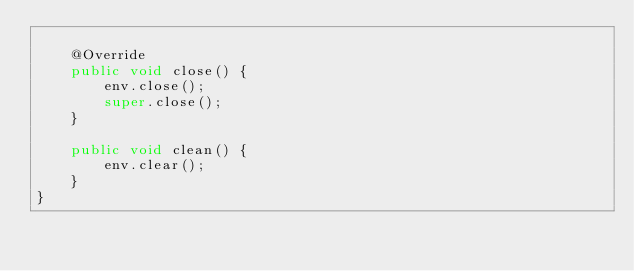Convert code to text. <code><loc_0><loc_0><loc_500><loc_500><_Java_>
    @Override
    public void close() {
        env.close();
        super.close();
    }

    public void clean() {
        env.clear();
    }
}
</code> 